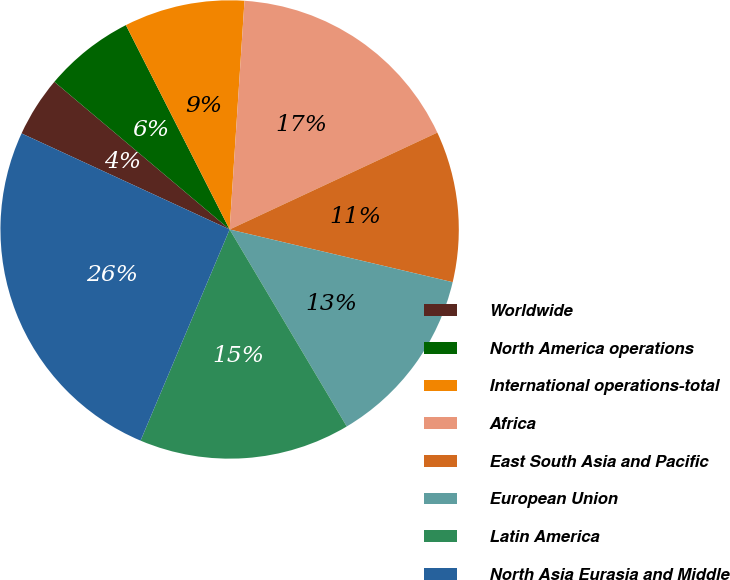Convert chart to OTSL. <chart><loc_0><loc_0><loc_500><loc_500><pie_chart><fcel>Worldwide<fcel>North America operations<fcel>International operations-total<fcel>Africa<fcel>East South Asia and Pacific<fcel>European Union<fcel>Latin America<fcel>North Asia Eurasia and Middle<nl><fcel>4.26%<fcel>6.38%<fcel>8.51%<fcel>17.02%<fcel>10.64%<fcel>12.77%<fcel>14.89%<fcel>25.53%<nl></chart> 